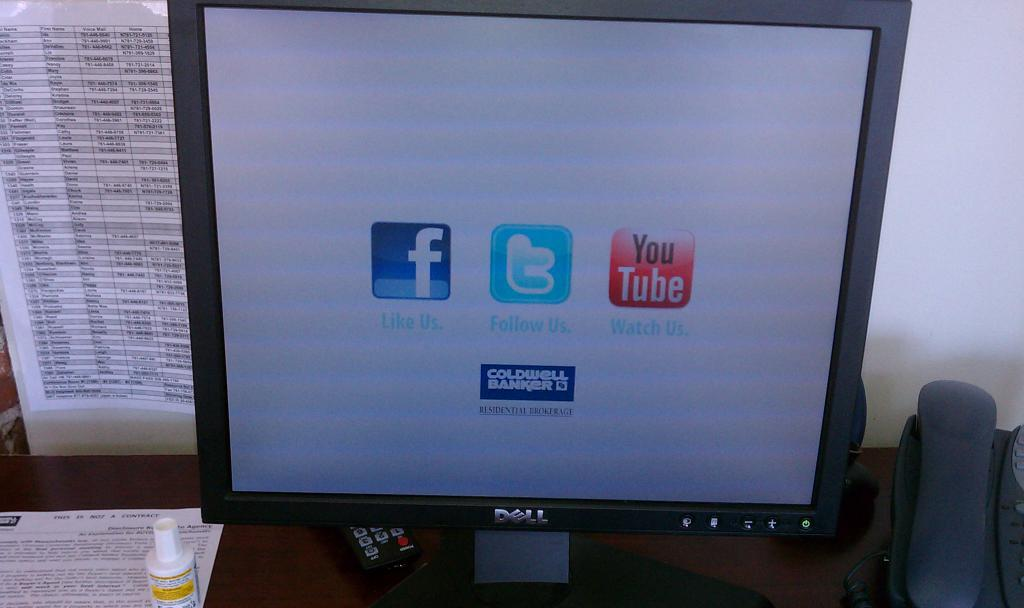<image>
Offer a succinct explanation of the picture presented. many icons on a screen that include YouTube 